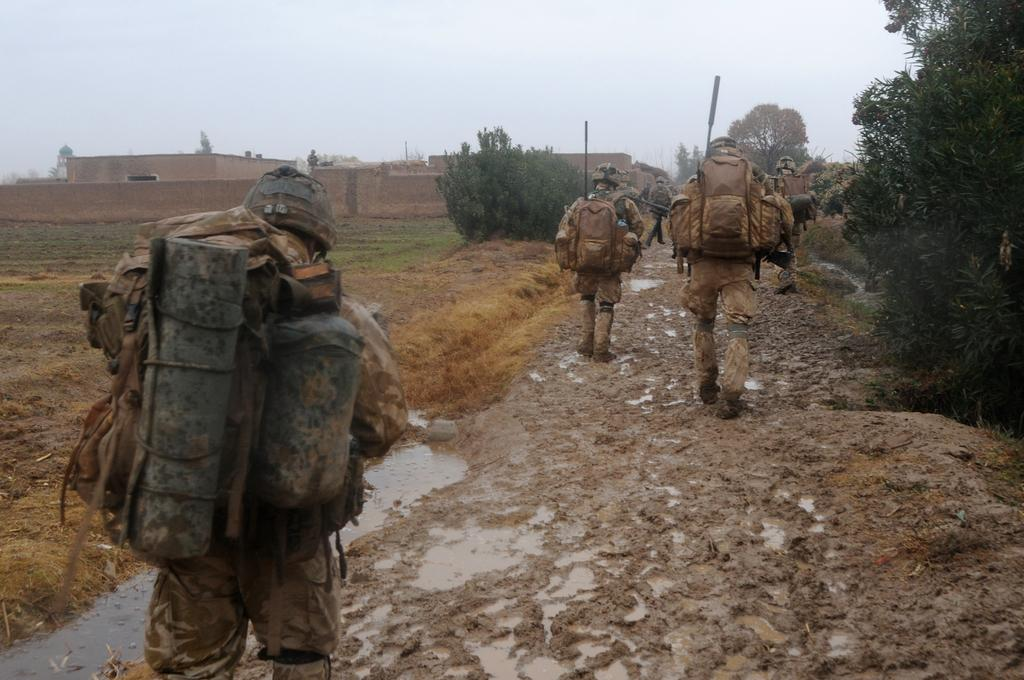What are the people in the image doing? The people in the image are walking on the land. What can be seen at the bottom of the image? There is water visible at the bottom of the image. What is in the background of the image? There are trees and a building in the background of the image. What is visible in the sky in the image? The sky is visible in the background of the image. What type of wood is being used to build the respect in the image? There is no mention of wood, respect, or any construction in the image. The image features people walking on land, water, trees, a building, and the sky. 